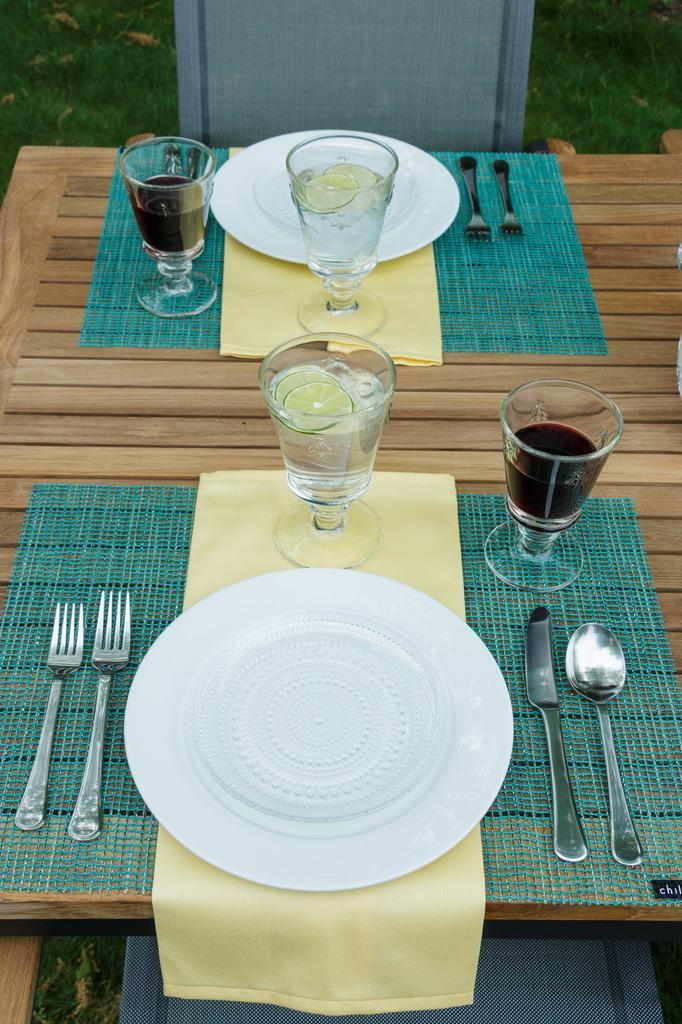Please provide a concise description of this image. This image is clicked in a garden. There is a table on which glasses, plates, spoons and knives are kept. The table is made up of wood. There are two chairs in the image. At the bottom, there is grass. 